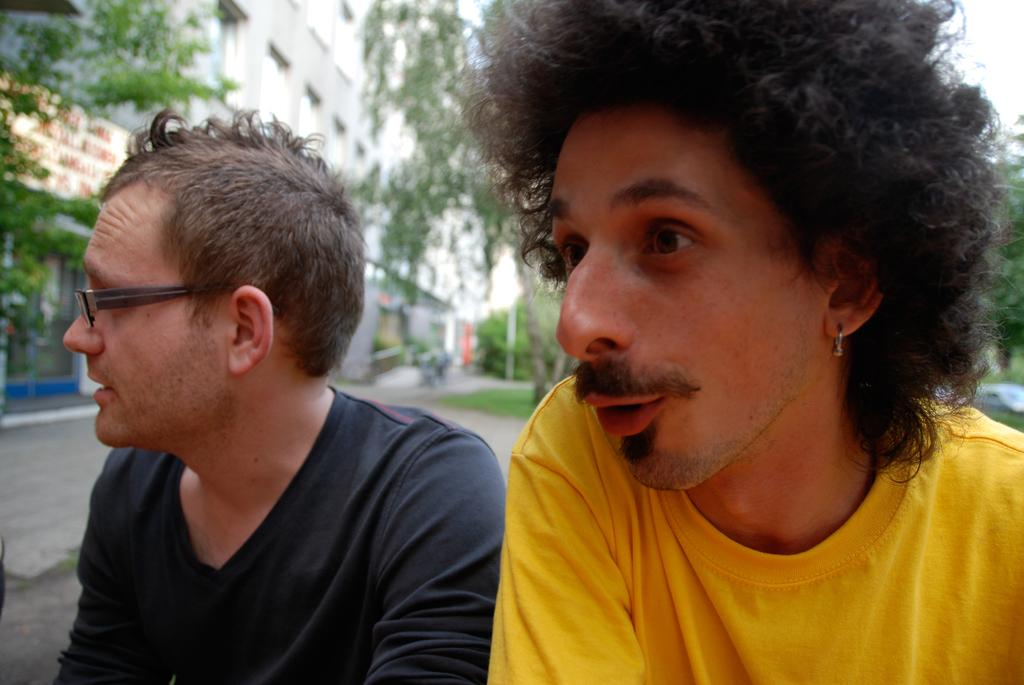How many people are in the image? There are two persons in the image. Where is the image taken? The image is taken on a road. What can be seen in the background of the image? There are trees, buildings, and grass in the background of the image. Are there any vehicles in the image? Yes, there are vehicles on the road in the image. What type of bucket is being used by the family in the image? There is no family or bucket present in the image. 